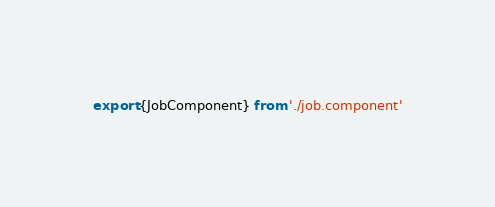Convert code to text. <code><loc_0><loc_0><loc_500><loc_500><_TypeScript_>export {JobComponent} from './job.component'
</code> 